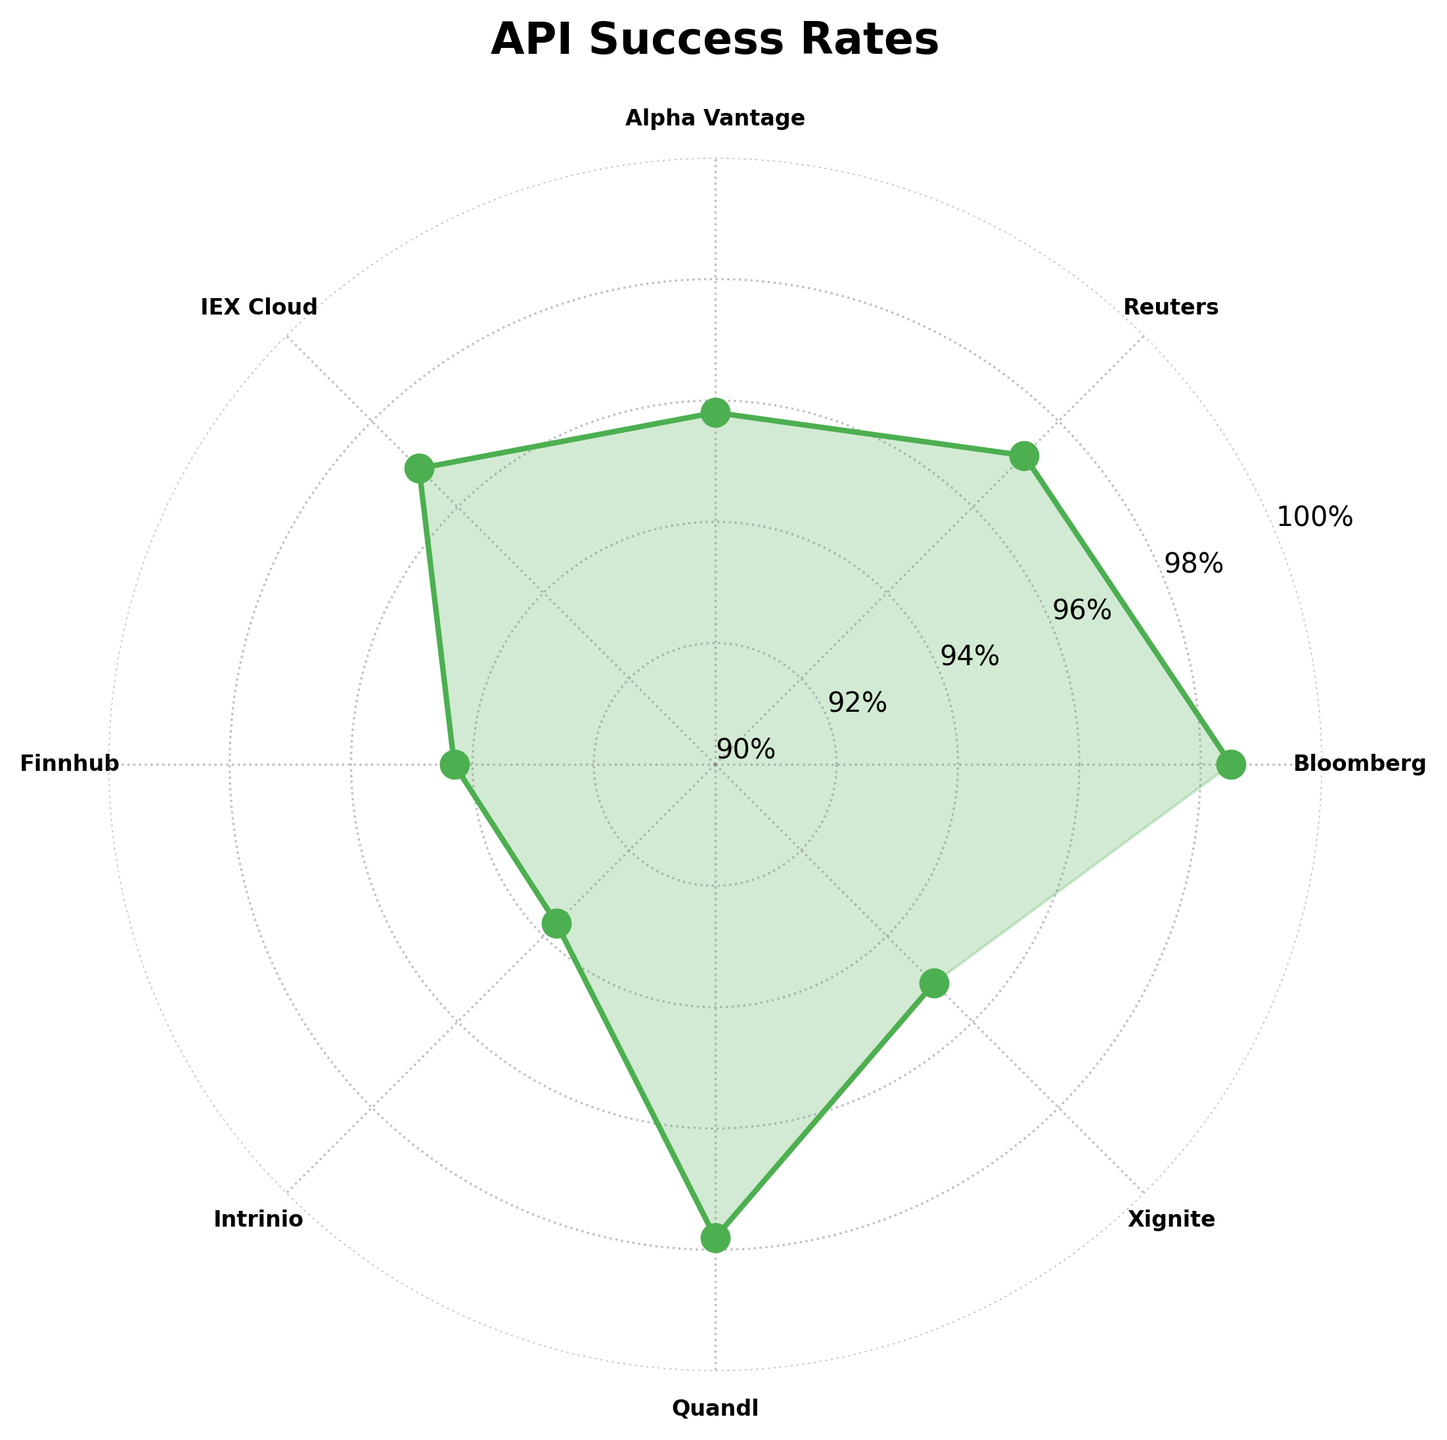What is the title of the chart? The title of the chart is displayed at the top of the figure. It reads "API Success Rates" with a bold font and is positioned centrally.
Answer: API Success Rates How many API providers are listed in the chart? Each provider is marked on the plot, denoted by the distinct labels around the polar plot. Counting these labels provides the total number of providers.
Answer: 8 Which API provider has the highest success rate? By identifying the point on the plot that reaches the highest percentage in the circular grid, and noting its corresponding label, we determine the provider with the highest rate.
Answer: Bloomberg What's the range of success rates displayed around the chart? Observing the values on the circular grid, the success rates can be seen starting from the outer grid at 90% up to the peak recorded value.
Answer: 90% to 98.5% How do the success rates of Reuters and Quandl compare? By locating their respective points on the radial plot and comparing their heights in the success rate percentages, we can see which provider has a higher rate. Reuters reaches up to 97.2%, while Quandl reaches 97.8%.
Answer: Quandl has a higher success rate What is the average success rate of all the API providers? Summing all the success rates (98.5 + 97.2 + 95.8 + 96.9 + 94.3 + 93.7 + 97.8 + 95.1) gives a total of 769.3. Dividing this by the number of providers (8) yields the average.
Answer: 96.16% Which API providers have success rates below 96%? Identifying the points that fall below the circular grid mark of 96% and noting their respective labels reveals the providers in question.
Answer: Alpha Vantage, Finnhub, Intrinio, Xignite What is the difference in success rate between the highest and lowest providers? Subtracting the lowest percentage (93.7 for Intrinio) from the highest (98.5 for Bloomberg) gives the difference.
Answer: 4.8% What is the median success rate of the API providers? Sorting the success rates in ascending order (93.7, 94.3, 95.1, 95.8, 96.9, 97.2, 97.8, 98.5) and finding the middle value between the fourth and fifth items (95.8 and 96.9) gives the median.
Answer: 96.35% Which two API providers have the smallest difference in their success rates? Comparing the differences between adjacent points on the plot, the smallest difference is between Reuters (97.2) and Quandl (97.8), with a difference of 0.6%.
Answer: Reuters and Quandl 